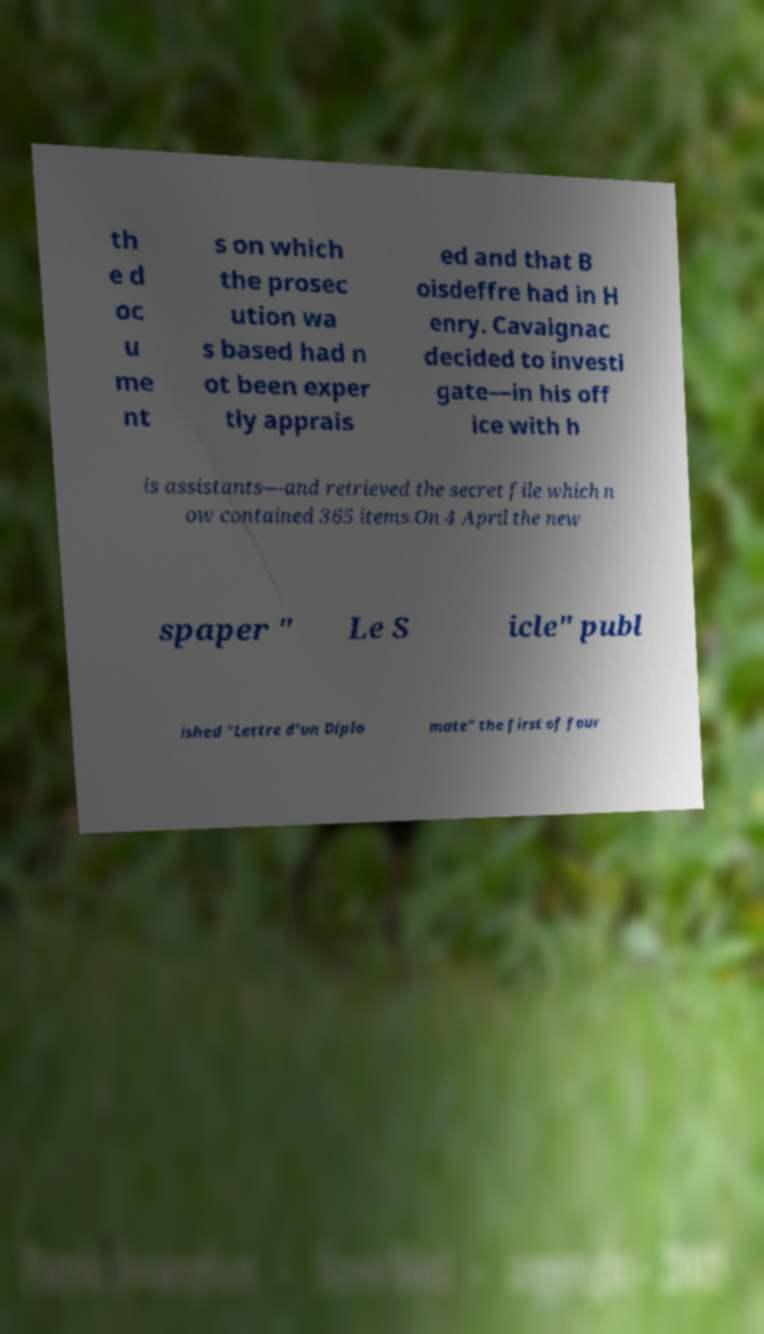I need the written content from this picture converted into text. Can you do that? th e d oc u me nt s on which the prosec ution wa s based had n ot been exper tly apprais ed and that B oisdeffre had in H enry. Cavaignac decided to investi gate—in his off ice with h is assistants—and retrieved the secret file which n ow contained 365 items.On 4 April the new spaper " Le S icle" publ ished "Lettre d'un Diplo mate" the first of four 